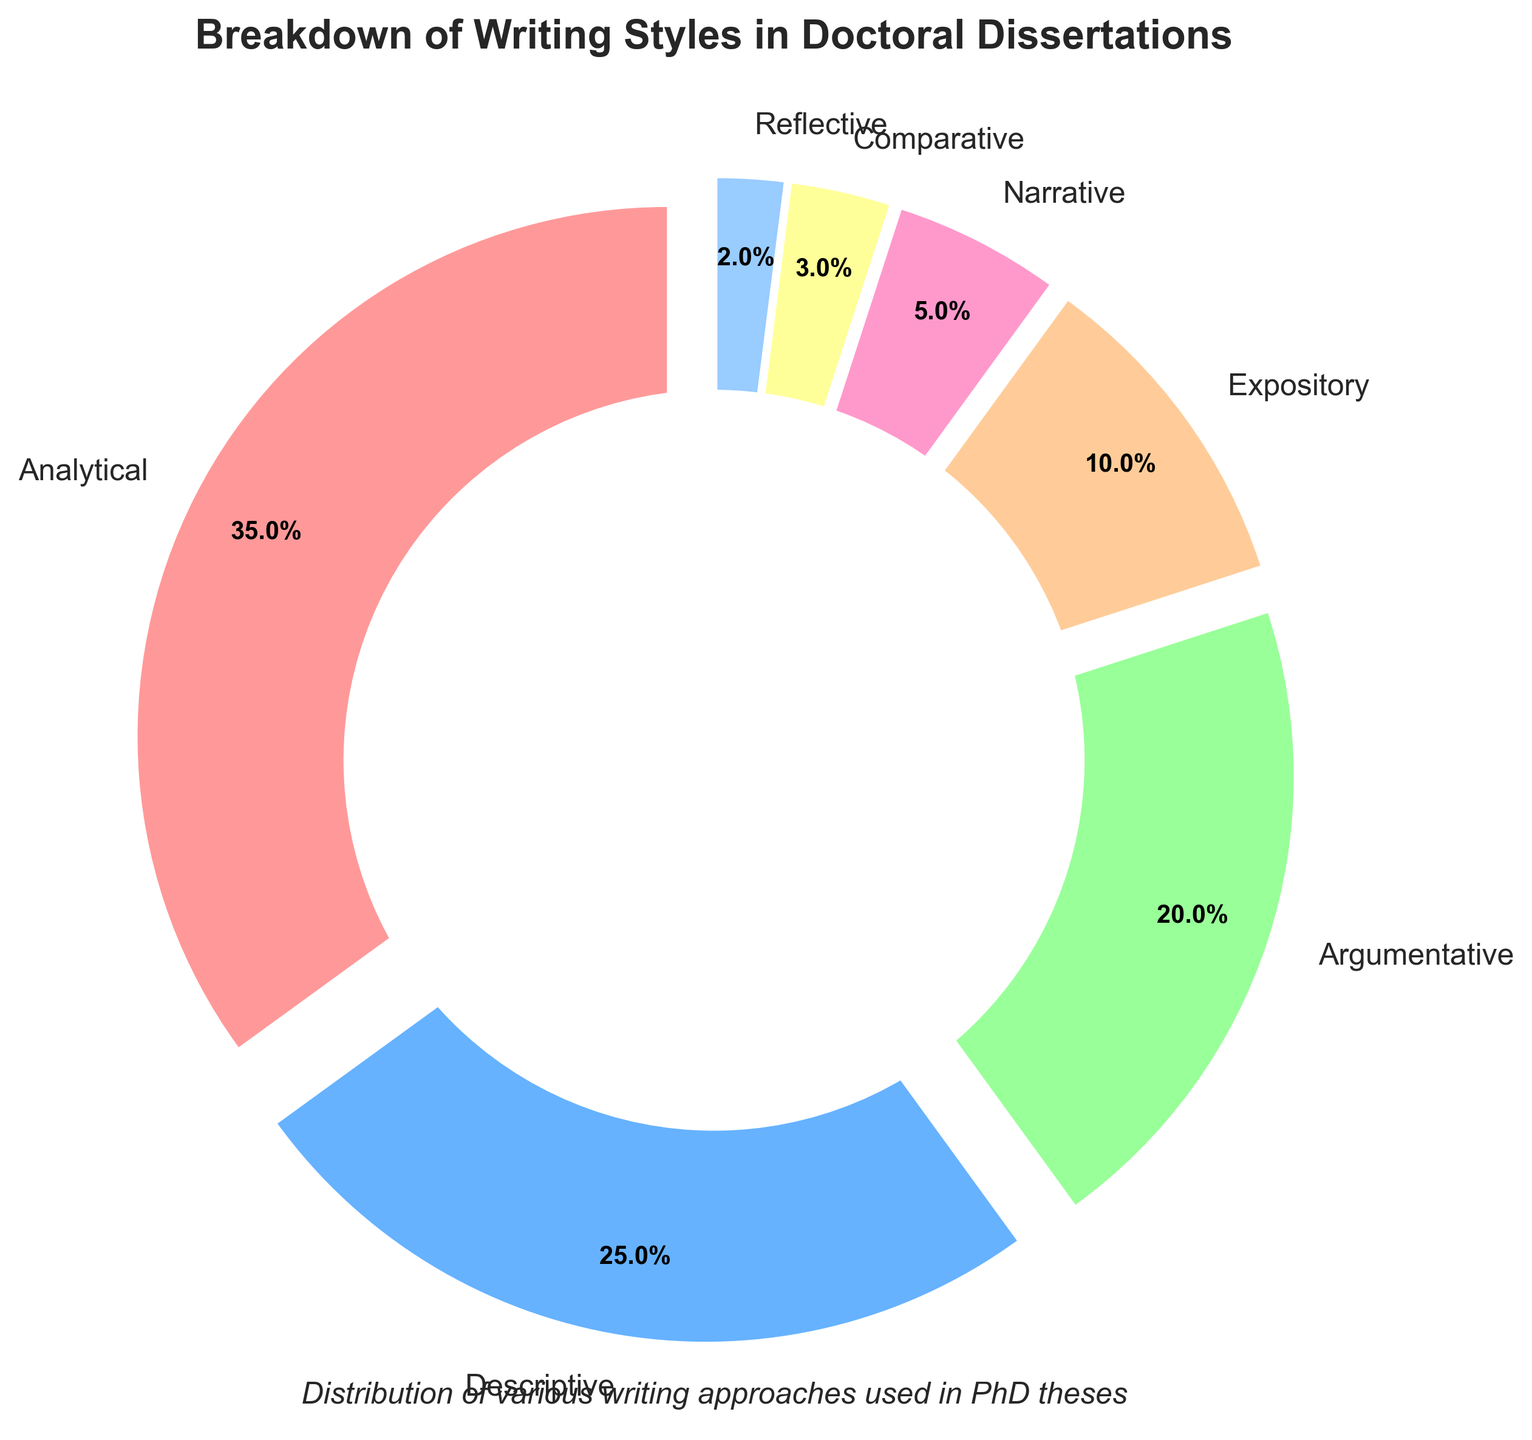Which writing style is used the most in doctoral dissertations? The pie chart shows the breakdown of writing styles with varying percentages. The segment labeled as 'Analytical' has the largest portion at 35%.
Answer: Analytical Which writing style is used the least in doctoral dissertations? By observing the pie chart, the smallest segment corresponds to 'Reflective' with a percentage of 2%.
Answer: Reflective What is the combined percentage of Descriptive and Argumentative writing styles? Descriptive has 25% and Argumentative has 20%. Adding these together, 25 + 20 = 45%.
Answer: 45% How much more is the Analytical writing style used compared to the Expository writing style? Analytical is 35% and Expository is 10%. Subtracting these values, 35 - 10 = 25%.
Answer: 25% Which writing style has a higher percentage, Narrative or Comparative? The chart shows that Narrative is 5% and Comparative is 3%. Therefore, Narrative has a higher percentage.
Answer: Narrative What is the total percentage of all writing styles excluding Analytical and Descriptive? Excluding Analytical (35%) and Descriptive (25%), the remaining styles are Argumentative (20%), Expository (10%), Narrative (5%), Comparative (3%), and Reflective (2%). Adding these up, 20 + 10 + 5 + 3 + 2 = 40%.
Answer: 40% What fraction of the total percentage is dedicated to Expository and Reflective writing styles combined? Expository is 10% and Reflective is 2%. Their combined percentage is 12%. Since the total is 100%, the fraction is 12/100 = 3/25.
Answer: 3/25 If the percentage of Descriptive writing were to increase by 10%, what would the new total for Descriptive be? The current percentage of Descriptive writing style is 25%. An increase by 10% would be calculated as 25 + 10 = 35%.
Answer: 35% Are there more dissertations using Narrative or Comparative writing styles, and by how much? Narrative has 5% while Comparative has 3%. The difference is 5 - 3 = 2%. Therefore, there are 2% more dissertations using Narrative.
Answer: 2% What is the average percentage of the following writing styles: Comparative, Reflective, and Narrative? Adding the percentages of Comparative (3%), Reflective (2%), and Narrative (5%) gives 3 + 2 + 5 = 10%. The average is 10% / 3 = 3.33%.
Answer: 3.33% 